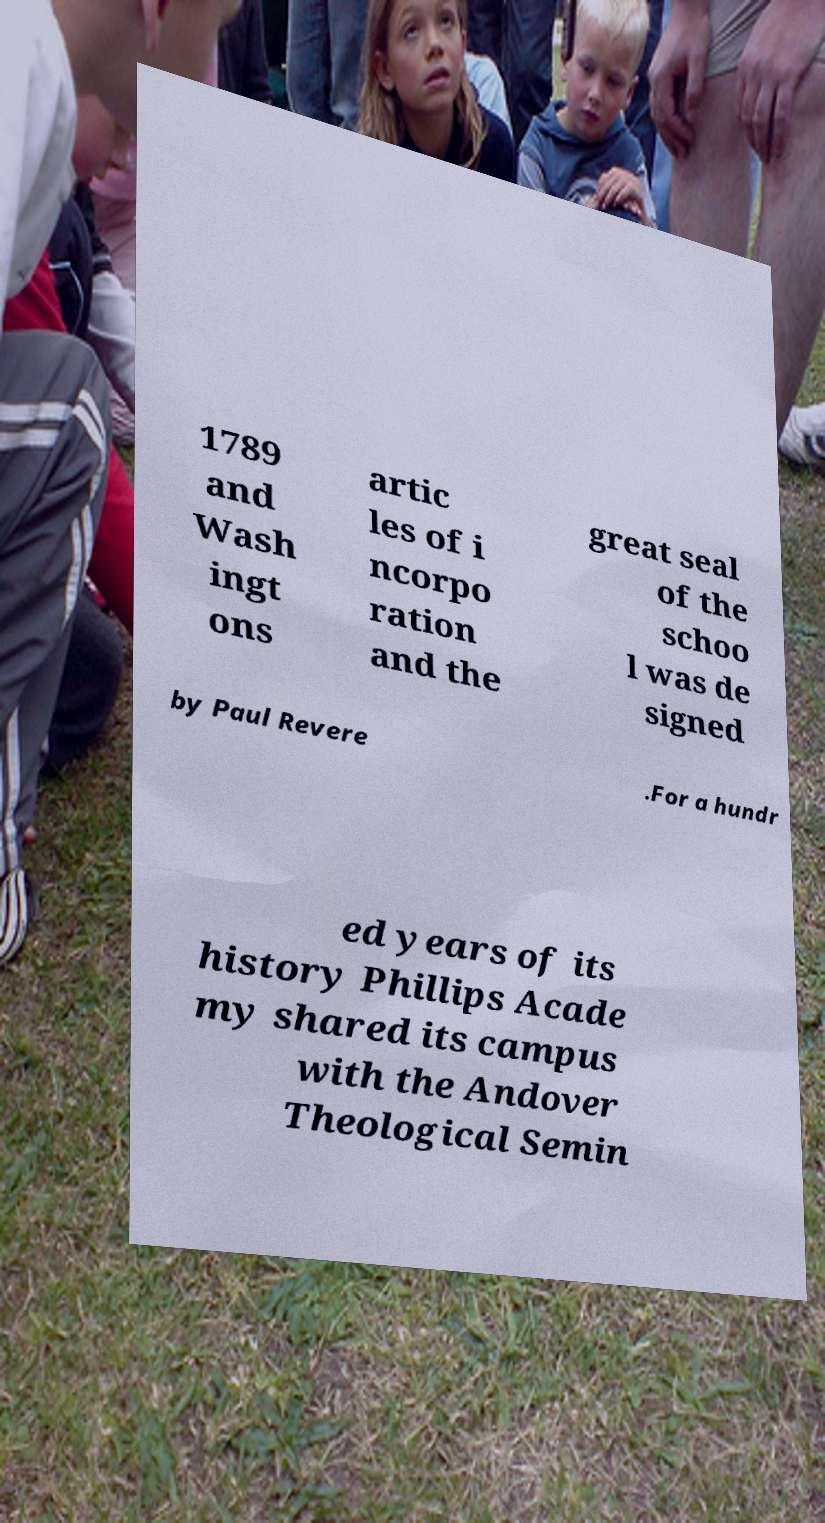Please identify and transcribe the text found in this image. 1789 and Wash ingt ons artic les of i ncorpo ration and the great seal of the schoo l was de signed by Paul Revere .For a hundr ed years of its history Phillips Acade my shared its campus with the Andover Theological Semin 